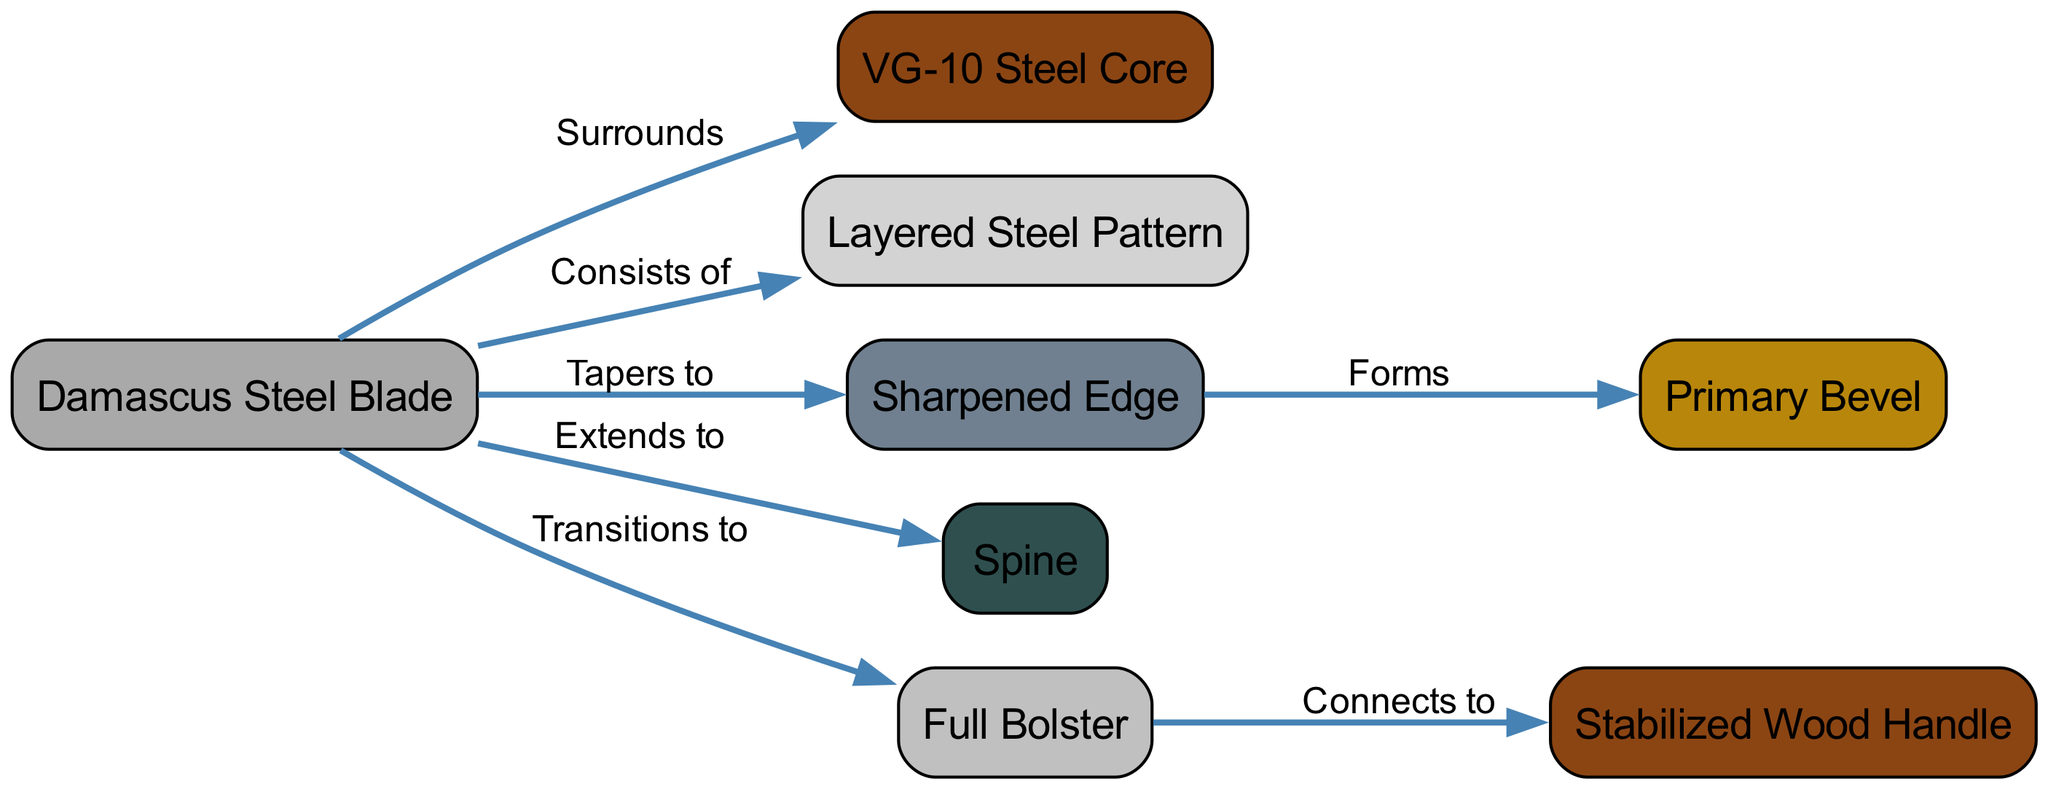What is the core material of the knife? The diagram clearly labels the core material of the knife as "VG-10 Steel Core." This information is directly associated with the node labeled "core."
Answer: VG-10 Steel Core Which part of the knife is connected to the bolster? According to the diagram, the bolster connects to the "Stabilized Wood Handle." The relationship is explicitly indicated in the edge labeled "Connects to."
Answer: Stabilized Wood Handle How many nodes are in the diagram? Counting each labeled node in the diagram gives us eight nodes: Damascus Steel Blade, VG-10 Steel Core, Layered Steel Pattern, Sharpened Edge, Primary Bevel, Spine, Full Bolster, and Stabilized Wood Handle.
Answer: 8 What does the edge taper to? The diagram indicates that the "Damascus Steel Blade" tapers to the "Sharpened Edge." This relationship is represented in the edge labeled "Tapers to."
Answer: Sharpened Edge Which component consists of layered steel? According to the diagram, the "Damascus Steel Blade" consists of "Layered Steel Pattern." This is shown in the edge labeled "Consists of."
Answer: Layered Steel Pattern Explain the relationship between the blade and the spine. The relationship depicted in the diagram states that the "Damascus Steel Blade" extends to the "Spine," indicating that the spine runs along the top of the blade, providing structural integrity and balance.
Answer: Spine What materials comprise the handle? The diagram shows that the handle is labeled as a "Stabilized Wood Handle." While it doesn't list specific types of wood, it indicates that it is stabilized, which usually implies a process involving resin or similar treatment, enhancing durability.
Answer: Stabilized Wood Handle What forms the primary bevel of the knife? The diagram clearly shows that the "Sharpened Edge" forms the "Primary Bevel," indicating the angled surface that is responsible for cutting. This relationship is explicitly noted in the edge labeled "Forms."
Answer: Primary Bevel 